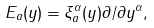Convert formula to latex. <formula><loc_0><loc_0><loc_500><loc_500>E _ { a } ( y ) = \xi _ { a } ^ { \alpha } ( y ) \partial / \partial y ^ { \alpha } ,</formula> 